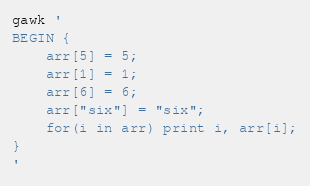Convert code to text. <code><loc_0><loc_0><loc_500><loc_500><_Awk_>gawk '
BEGIN { 
	arr[5] = 5;
	arr[1] = 1;
	arr[6] = 6;
	arr["six"] = "six";
	for(i in arr) print i, arr[i];
}
'
</code> 